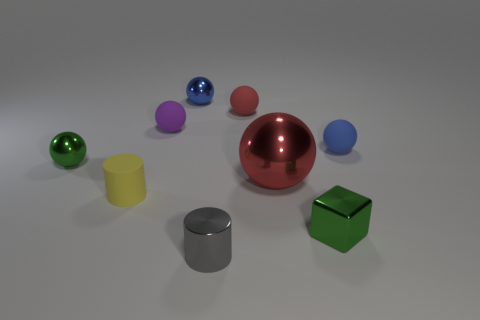Is the size of the shiny thing on the left side of the purple ball the same as the yellow cylinder? The shiny object to the left of the purple ball, which appears to be a blue sphere, is not quite the same size as the yellow cylinder. The blue sphere is actually smaller in diameter when closely inspected. 